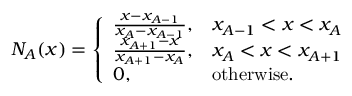Convert formula to latex. <formula><loc_0><loc_0><loc_500><loc_500>N _ { A } ( x ) = \left \{ \begin{array} { l l } { \frac { x - x _ { A - 1 } } { x _ { A } - x _ { A - 1 } } , } & { x _ { A - 1 } < x < x _ { A } } \\ { \frac { x _ { A + 1 } - x } { x _ { A + 1 } - x _ { A } } , } & { x _ { A } < x < x _ { A + 1 } } \\ { 0 , } & { o t h e r w i s e . } \end{array}</formula> 